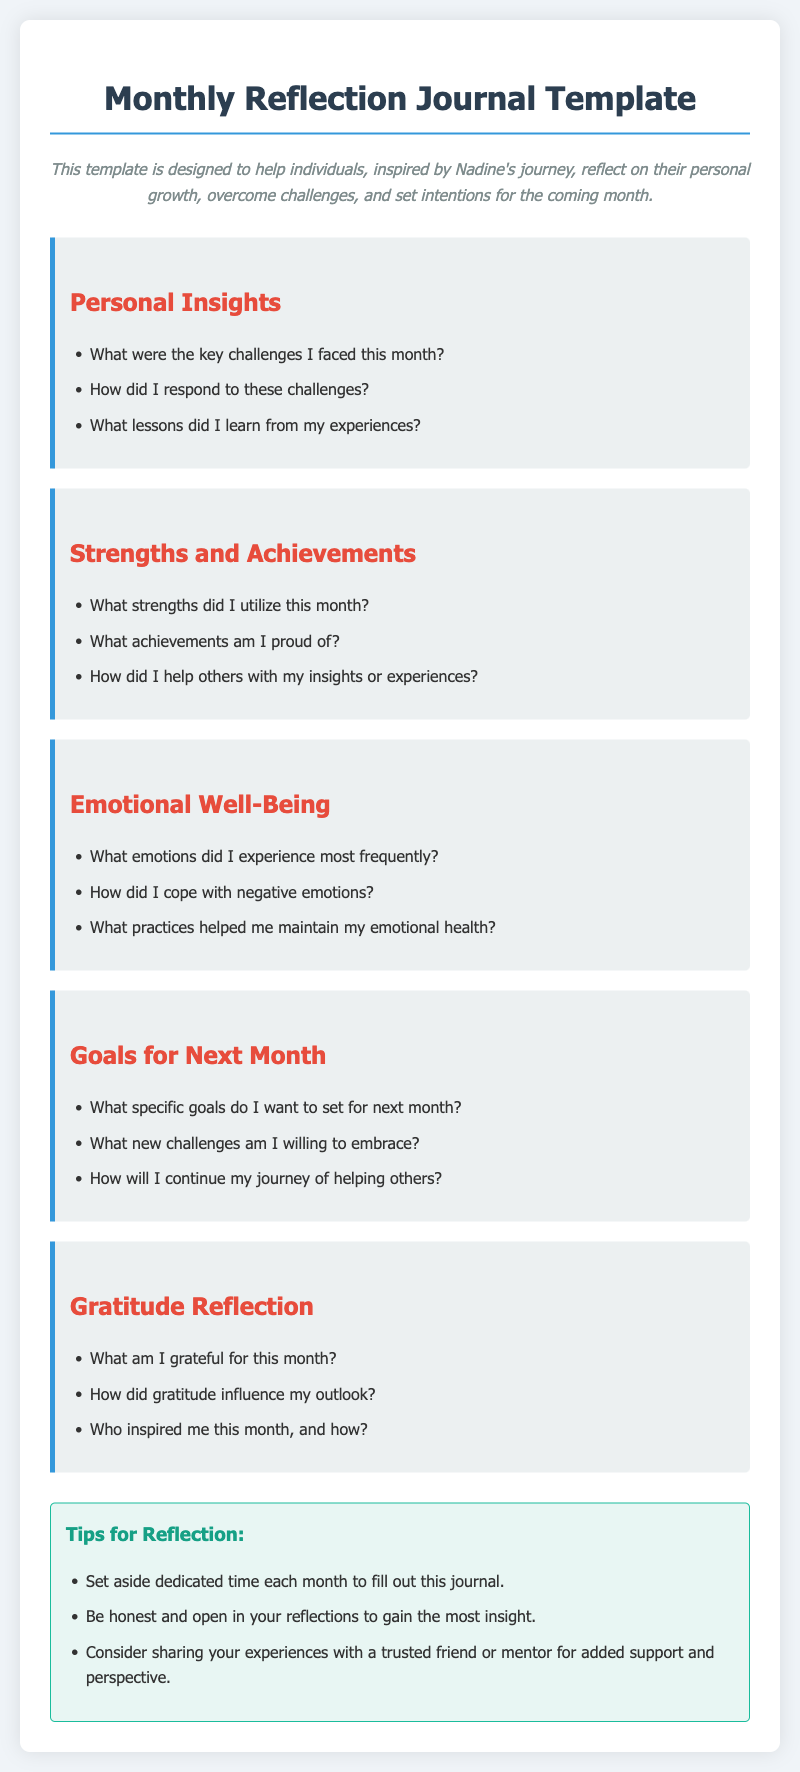What is the title of the document? The title of the document is the main header found at the top of the page.
Answer: Monthly Reflection Journal Template What is the primary purpose of the journal template? The purpose is described in the introductory paragraph of the document.
Answer: To help individuals reflect on their personal growth What section discusses emotional health? The specific section dedicated to this topic is clearly labeled in the document.
Answer: Emotional Well-Being How many questions are there in the 'Goals for Next Month' section? This can be determined by counting the list items under that section in the document.
Answer: Three What color are the section headings? The color can be found in the CSS styles applied to the headings throughout the document.
Answer: Red What is one tip for reflection provided in the document? This information is found in the tips section, which has multiple suggestions.
Answer: Set aside dedicated time each month What are the three key areas evaluated in the 'Strengths and Achievements' section? The document lists key areas specifically tailored to this section.
Answer: Strengths utilized, achievements, helping others Who is the inspiration mentioned in the description? The description credits a specific individual for the inspiration behind the journal.
Answer: Nadine What influences are discussed in relation to gratitude? The document mentions a specific aspect regarding the impact of gratitude on emotional state.
Answer: Gratitude influenced my outlook 